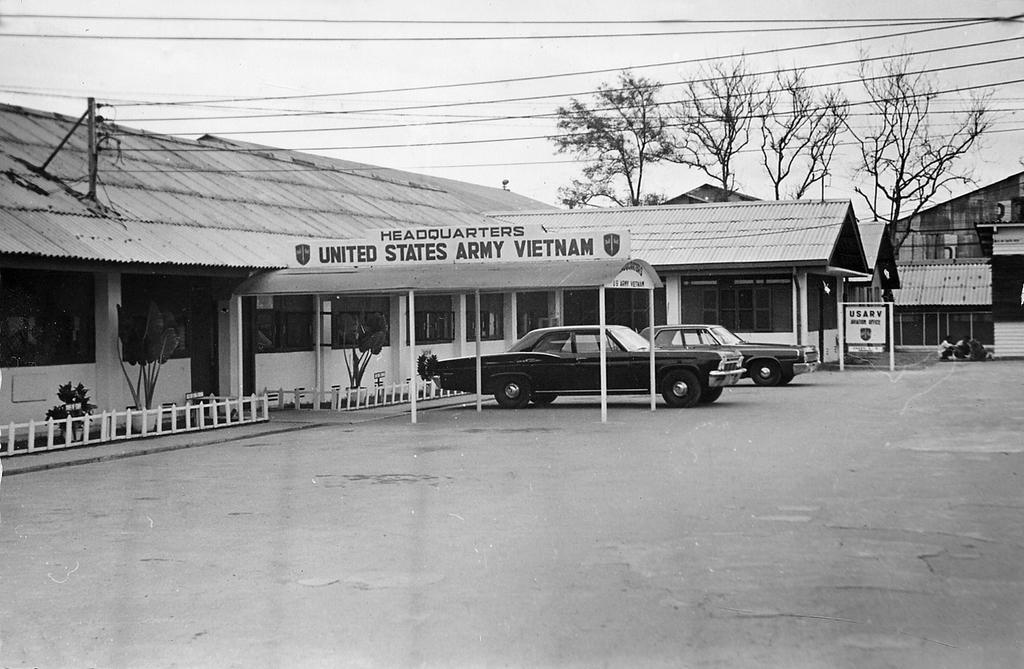What is the color scheme of the image? The image is black and white. What can be seen in front of the shed? There are cars in front of the shed. What type of vegetation is on the right side of the image? There are trees on the right side of the image. What is visible at the top of the image? There are wires and the sky visible at the top of the image. Can you see the moon in the image? No, the moon is not visible in the image. Is there a goose playing a game with the cars in the image? There is no goose or game involving the cars in the image. 